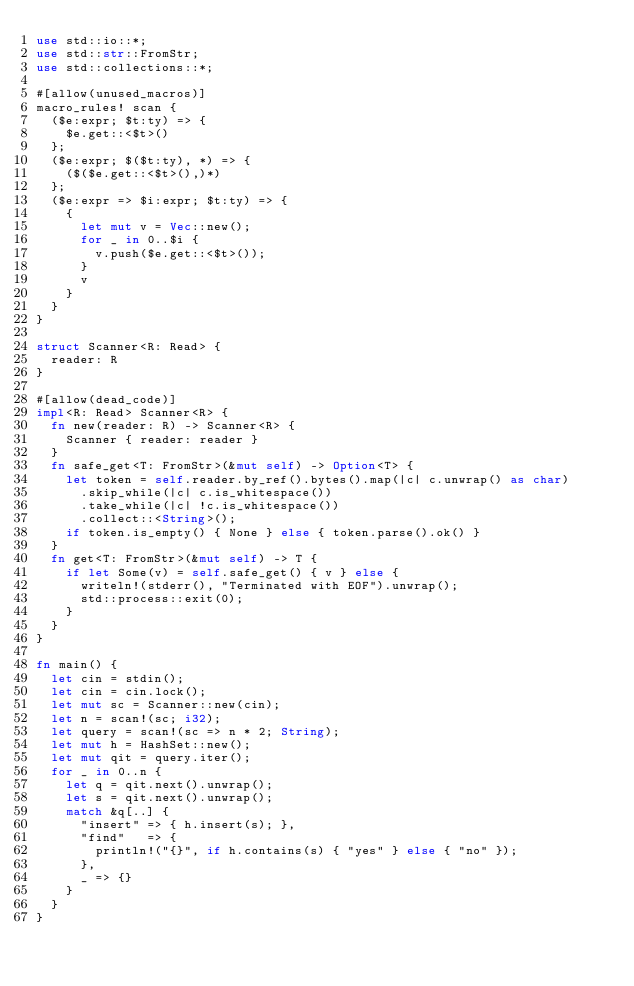Convert code to text. <code><loc_0><loc_0><loc_500><loc_500><_Rust_>use std::io::*;
use std::str::FromStr;
use std::collections::*;

#[allow(unused_macros)]
macro_rules! scan {
  ($e:expr; $t:ty) => {
    $e.get::<$t>()
  };
  ($e:expr; $($t:ty), *) => {
    ($($e.get::<$t>(),)*)
  };
  ($e:expr => $i:expr; $t:ty) => {
    {
      let mut v = Vec::new();
      for _ in 0..$i {
        v.push($e.get::<$t>());
      }
      v
    }
  }
}

struct Scanner<R: Read> {
  reader: R
}

#[allow(dead_code)]
impl<R: Read> Scanner<R> {
  fn new(reader: R) -> Scanner<R> {
    Scanner { reader: reader }
  }
  fn safe_get<T: FromStr>(&mut self) -> Option<T> {
    let token = self.reader.by_ref().bytes().map(|c| c.unwrap() as char)
      .skip_while(|c| c.is_whitespace())
      .take_while(|c| !c.is_whitespace())
      .collect::<String>();
    if token.is_empty() { None } else { token.parse().ok() }
  }
  fn get<T: FromStr>(&mut self) -> T {
    if let Some(v) = self.safe_get() { v } else {
      writeln!(stderr(), "Terminated with EOF").unwrap();
      std::process::exit(0);
    }
  }
}

fn main() {
  let cin = stdin();
  let cin = cin.lock();
  let mut sc = Scanner::new(cin);
  let n = scan!(sc; i32);
  let query = scan!(sc => n * 2; String);
  let mut h = HashSet::new();
  let mut qit = query.iter();
  for _ in 0..n {
    let q = qit.next().unwrap();
    let s = qit.next().unwrap();
    match &q[..] {
      "insert" => { h.insert(s); },
      "find"   => {
        println!("{}", if h.contains(s) { "yes" } else { "no" });
      },
      _ => {}
    }
  }
}

</code> 